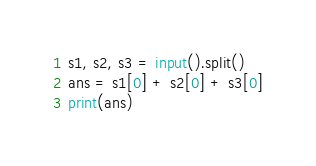Convert code to text. <code><loc_0><loc_0><loc_500><loc_500><_Python_>s1, s2, s3 = input().split()
ans = s1[0] + s2[0] + s3[0]
print(ans)</code> 